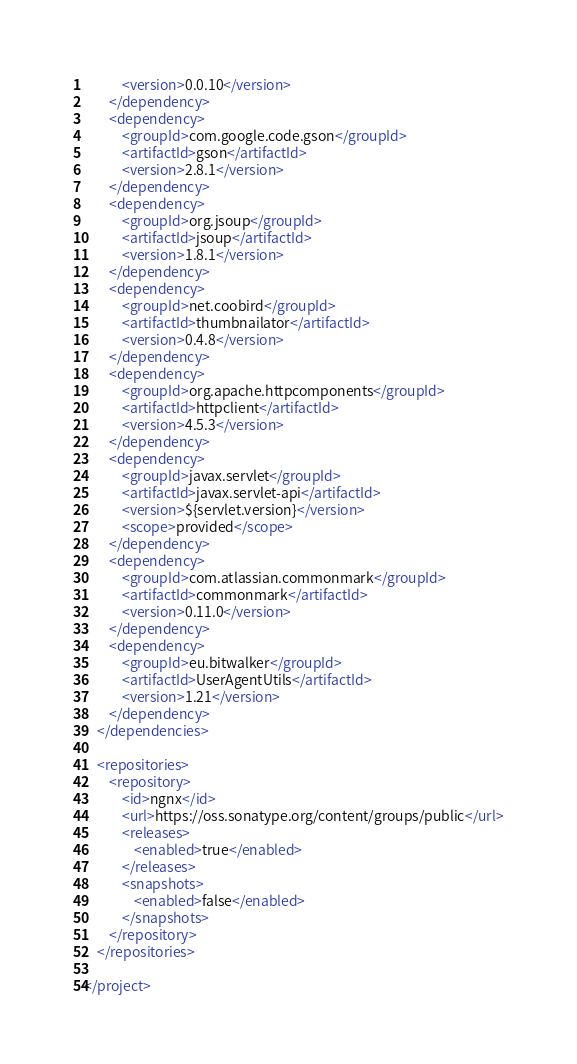Convert code to text. <code><loc_0><loc_0><loc_500><loc_500><_XML_>            <version>0.0.10</version>
        </dependency>
        <dependency>
            <groupId>com.google.code.gson</groupId>
            <artifactId>gson</artifactId>
            <version>2.8.1</version>
        </dependency>
        <dependency>
            <groupId>org.jsoup</groupId>
            <artifactId>jsoup</artifactId>
            <version>1.8.1</version>
        </dependency>
        <dependency>
            <groupId>net.coobird</groupId>
            <artifactId>thumbnailator</artifactId>
            <version>0.4.8</version>
        </dependency>
        <dependency>
            <groupId>org.apache.httpcomponents</groupId>
            <artifactId>httpclient</artifactId>
            <version>4.5.3</version>
        </dependency>
        <dependency>
            <groupId>javax.servlet</groupId>
            <artifactId>javax.servlet-api</artifactId>
            <version>${servlet.version}</version>
            <scope>provided</scope>
        </dependency>
        <dependency>
            <groupId>com.atlassian.commonmark</groupId>
            <artifactId>commonmark</artifactId>
            <version>0.11.0</version>
        </dependency>
        <dependency>
            <groupId>eu.bitwalker</groupId>
            <artifactId>UserAgentUtils</artifactId>
            <version>1.21</version>
        </dependency>
    </dependencies>

    <repositories>
        <repository>
            <id>ngnx</id>
            <url>https://oss.sonatype.org/content/groups/public</url>
            <releases>
                <enabled>true</enabled>
            </releases>
            <snapshots>
                <enabled>false</enabled>
            </snapshots>
        </repository>
    </repositories>

</project></code> 